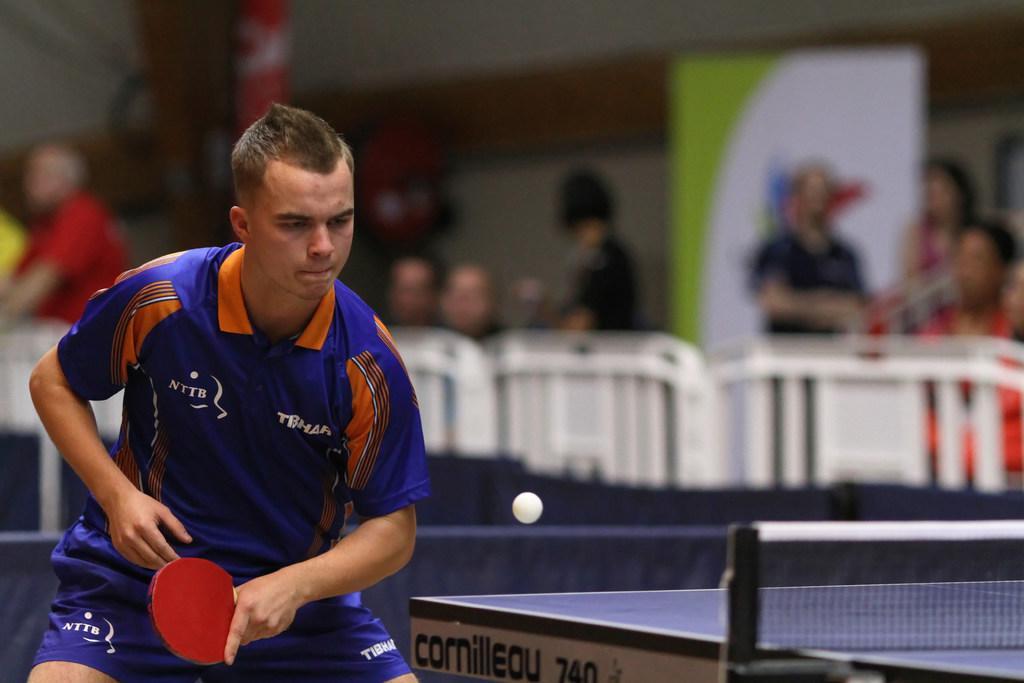Can you describe this image briefly? In this image there is a person standing and holding a red bat and playing a game. At the back there are group of people and there is a hoarding. 